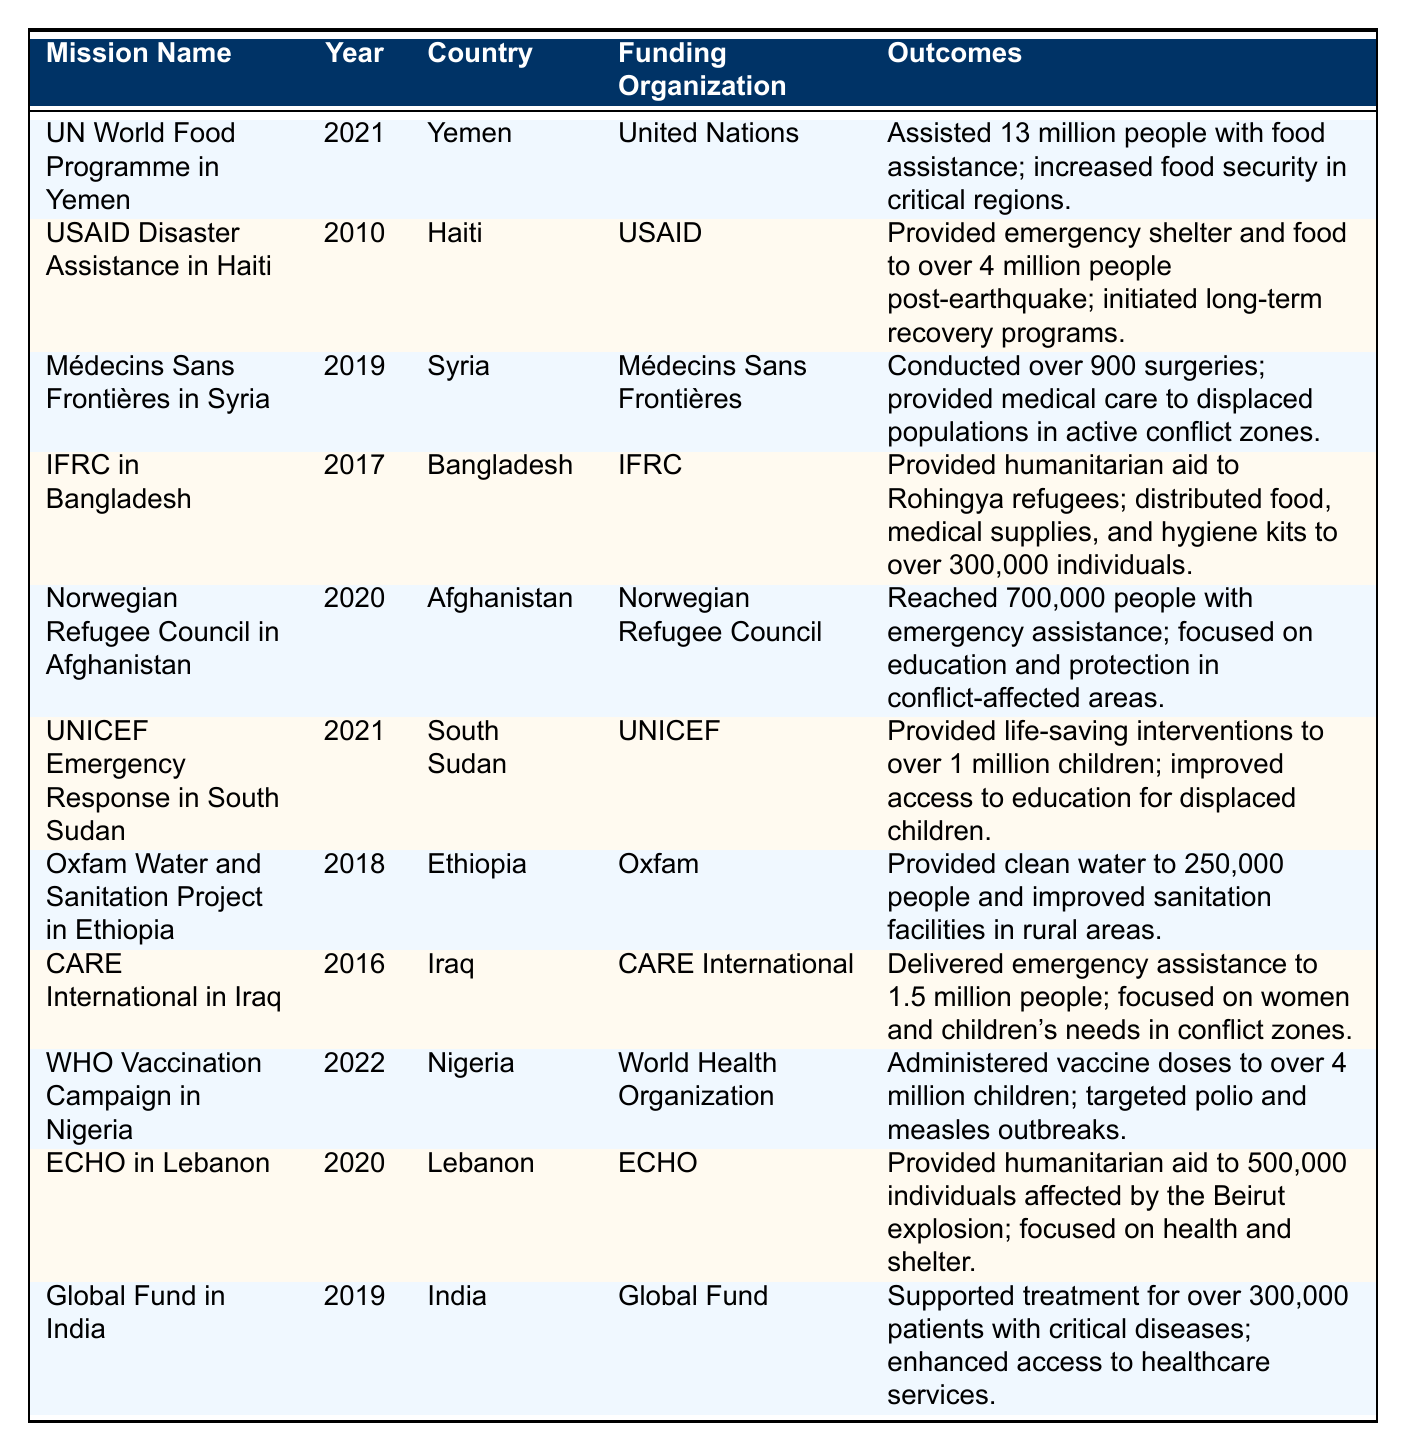What is the year of the mission conducted by UNICEF in South Sudan? The table lists the missions along with their corresponding years. By locating the UNICEF Emergency Response in South Sudan, we find that it was conducted in the year 2021.
Answer: 2021 Which funding organization assisted over 4 million people in Haiti after the earthquake? By scanning the table, we find that USAID Disaster Assistance in Haiti is the mission that provided emergency shelter and food to over 4 million people post-earthquake, indicating that USAID is the funding organization involved.
Answer: USAID How many people did the World Health Organization's vaccination campaign reach in Nigeria? The table states that the WHO Vaccination Campaign in Nigeria administered vaccine doses to over 4 million children, thus indicating the number of people reached through the campaign.
Answer: Over 4 million Which mission had a focus on women's and children's needs in conflict zones? Looking at the table, we see that CARE International in Iraq delivered emergency assistance with a specific focus on women and children's needs in conflict zones.
Answer: CARE International in Iraq In which country did the Norwegian Refugee Council provide emergency assistance to 700,000 individuals? The mission conducted by the Norwegian Refugee Council is listed in the table as occurring in Afghanistan, where they reached 700,000 people.
Answer: Afghanistan How many missions are listed as occurring in the year 2021? By counting the entries in the table for the year 2021, we find there are two missions: the United Nations World Food Programme in Yemen and the UNICEF Emergency Response in South Sudan. Thus, there are 2 missions.
Answer: 2 Is it true that the International Federation of Red Cross focused on providing aid to Rohingya refugees? The outcomes for the IFRC mission in Bangladesh explicitly state that they provided humanitarian aid to Rohingya refugees, confirming that this statement is true.
Answer: Yes Which mission provided clean water to 250,000 people, and what year did it take place? By examining the table, we see that the Oxfam Water and Sanitation Project in Ethiopia provided clean water to 250,000 people in the year 2018.
Answer: Oxfam Water and Sanitation Project in Ethiopia; 2018 What is the total number of individuals served directly by the Norwegian Refugee Council in Afghanistan and the CARE International mission in Iraq combined? The Norwegian Refugee Council reached 700,000 people and CARE International delivered assistance to 1.5 million people. Adding these figures together gives 700,000 + 1,500,000 = 2,200,000 people served in total.
Answer: 2,200,000 Which organization was involved in the vaccination campaign aimed at polio and measles in Nigeria? The table specifies that the World Health Organization was responsible for administering vaccines aimed at polio and measles outbreaks in Nigeria, matching the criteria of the question.
Answer: World Health Organization How many individuals did the European Civil Protection and Humanitarian Aid Operations serve in Lebanon in 2020? According to the data, the ECHO mission provided humanitarian aid to 500,000 individuals affected by the Beirut explosion in Lebanon in 2020.
Answer: 500,000 